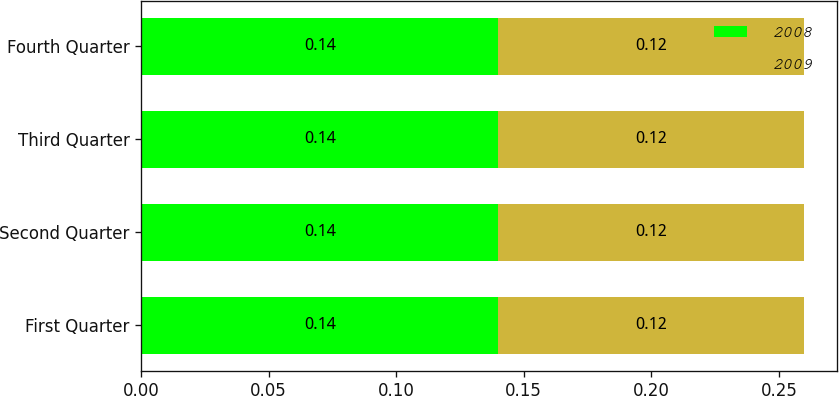Convert chart to OTSL. <chart><loc_0><loc_0><loc_500><loc_500><stacked_bar_chart><ecel><fcel>First Quarter<fcel>Second Quarter<fcel>Third Quarter<fcel>Fourth Quarter<nl><fcel>2008<fcel>0.14<fcel>0.14<fcel>0.14<fcel>0.14<nl><fcel>2009<fcel>0.12<fcel>0.12<fcel>0.12<fcel>0.12<nl></chart> 